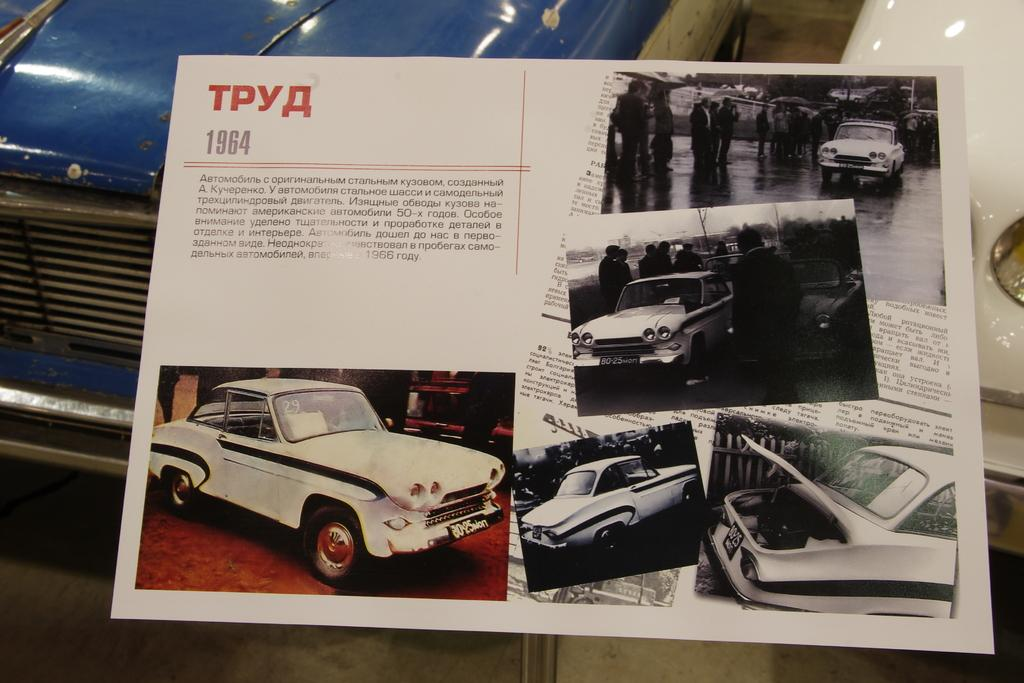What is the main subject in the image? There is a vehicle in the image. What can be seen beside the vehicle? There is an object beside the vehicle. What is located in the foreground of the image? There is a poster in the foreground of the image. What type of images are on the poster? The poster contains images of a car. What else is present on the poster besides the images? The poster has some text on it. What type of riddle can be solved using the sorting method in the image? There is no riddle or sorting method present in the image. What kind of pest can be seen crawling on the poster in the image? There are no pests visible on the poster or in the image. 